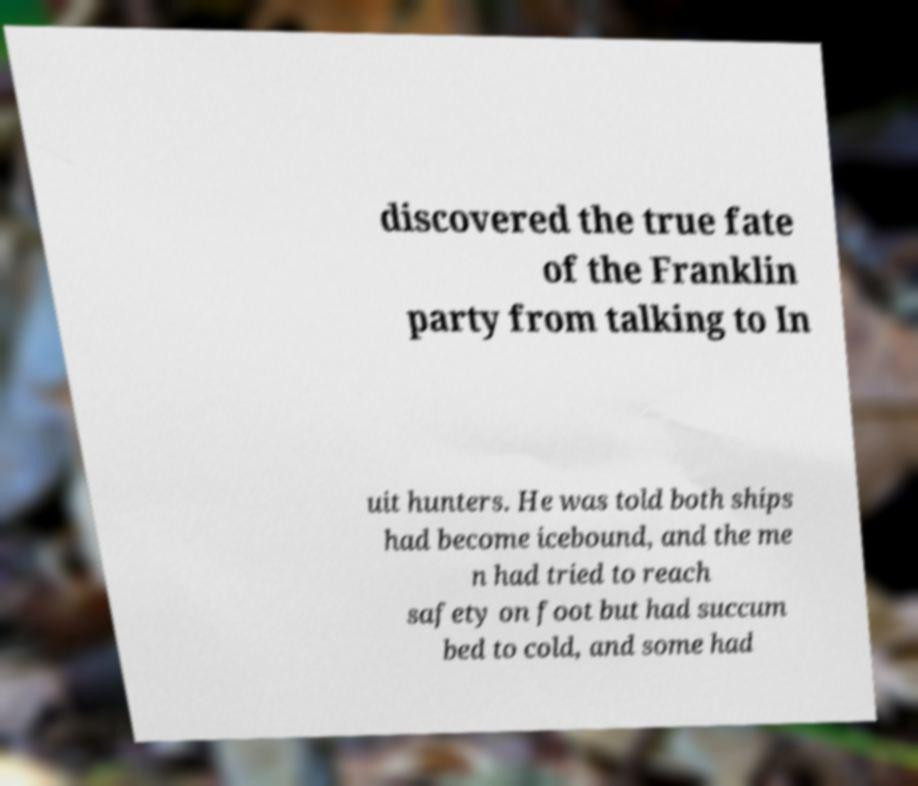What messages or text are displayed in this image? I need them in a readable, typed format. discovered the true fate of the Franklin party from talking to In uit hunters. He was told both ships had become icebound, and the me n had tried to reach safety on foot but had succum bed to cold, and some had 